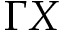<formula> <loc_0><loc_0><loc_500><loc_500>\Gamma X</formula> 